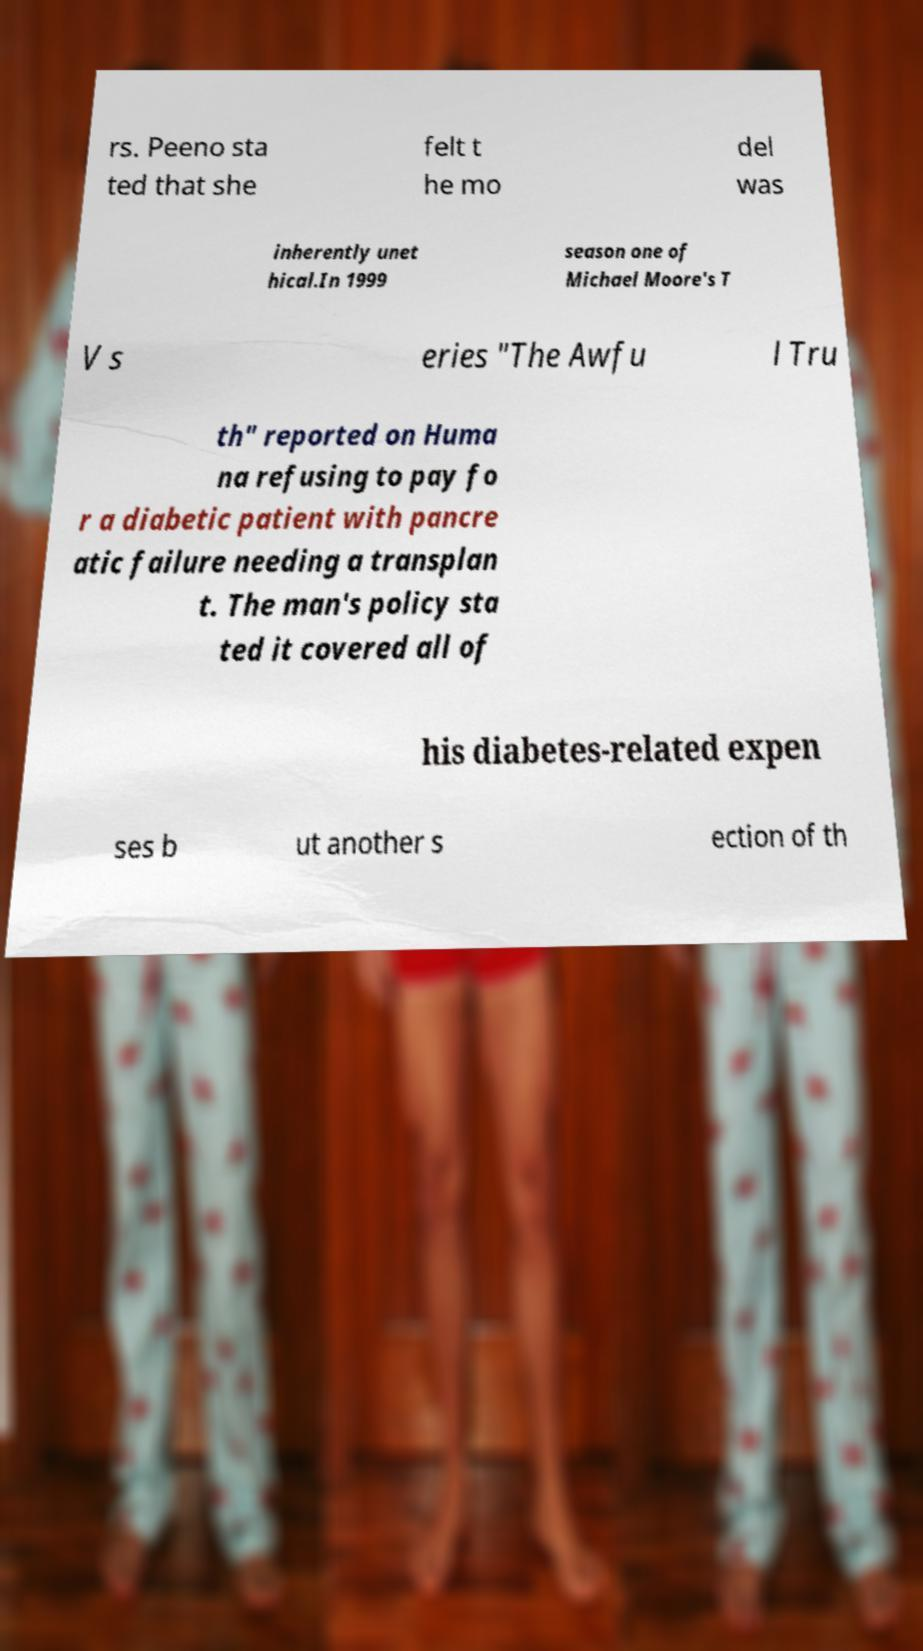What messages or text are displayed in this image? I need them in a readable, typed format. rs. Peeno sta ted that she felt t he mo del was inherently unet hical.In 1999 season one of Michael Moore's T V s eries "The Awfu l Tru th" reported on Huma na refusing to pay fo r a diabetic patient with pancre atic failure needing a transplan t. The man's policy sta ted it covered all of his diabetes-related expen ses b ut another s ection of th 